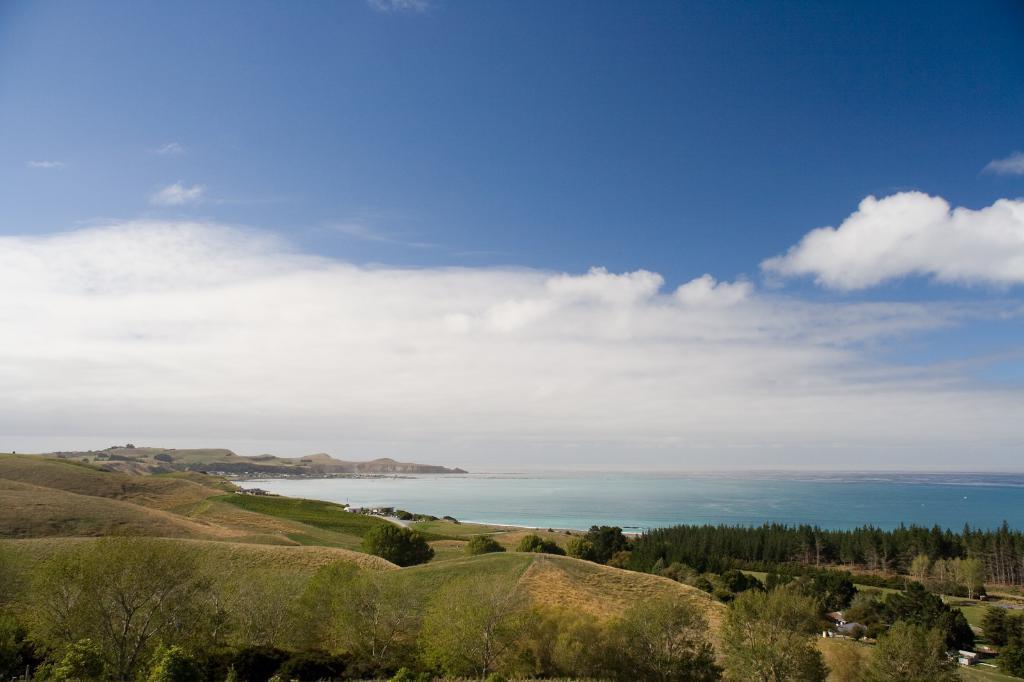How would you summarize this image in a sentence or two? In this picture I can see the sky at the top and in the middle I can see the ocean and around the ocean I can see trees and bushes and the hill. 